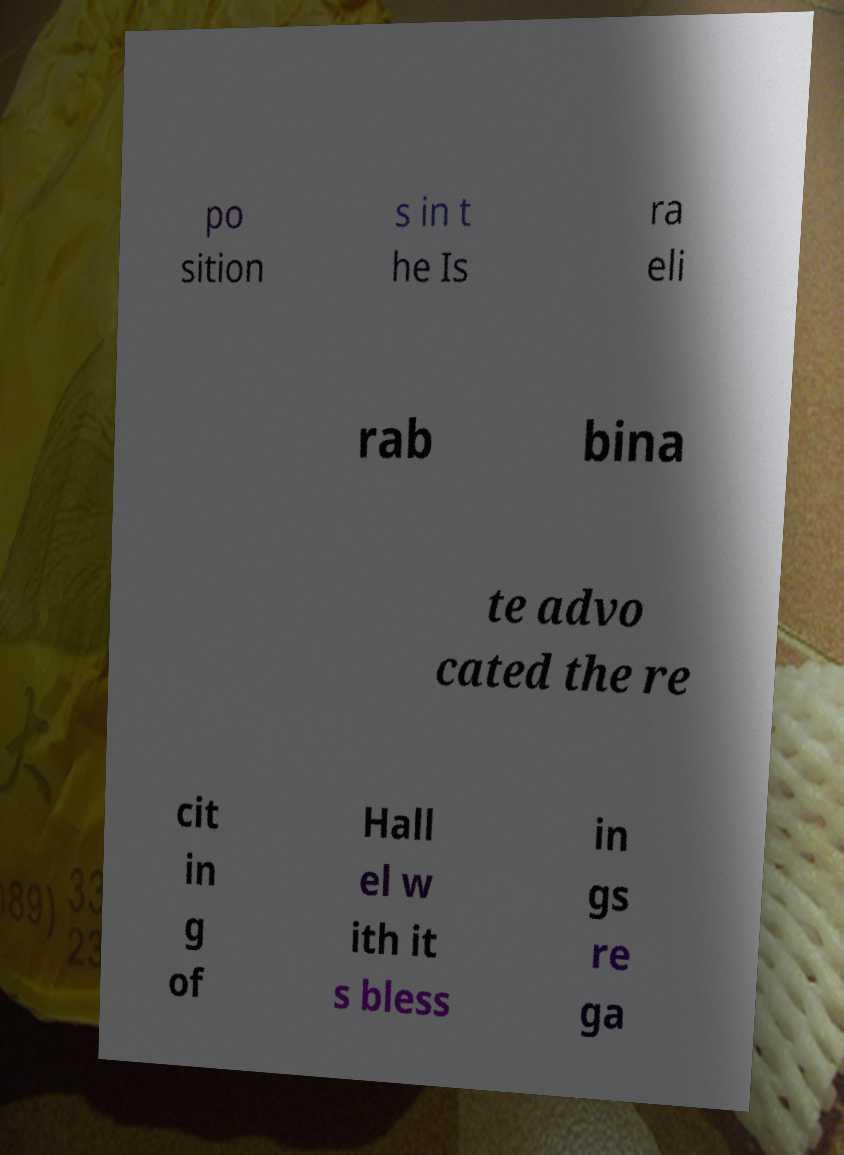Please read and relay the text visible in this image. What does it say? po sition s in t he Is ra eli rab bina te advo cated the re cit in g of Hall el w ith it s bless in gs re ga 